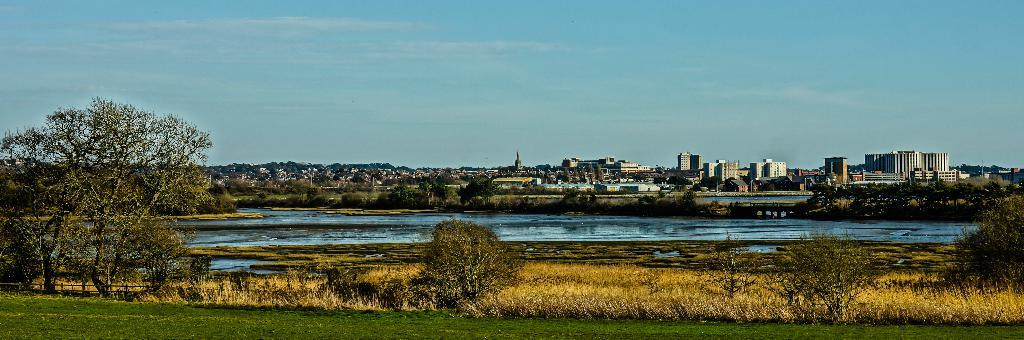What type of terrain is visible in the image? There is grass on the ground in the image. What other natural elements can be seen in the image? There are trees and water visible in the image. Are there any man-made structures present in the image? Yes, there are buildings in the image. What can be seen in the background of the image? The sky is visible in the background of the image. How many mountains are visible in the image? There are no mountains present in the image. What type of low-hanging fruit can be seen in the image? There is no fruit visible in the image. 